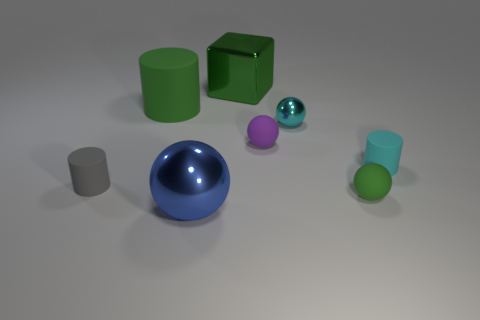How many small things are brown metallic cylinders or cyan metallic things?
Offer a very short reply. 1. Are there any gray objects?
Give a very brief answer. Yes. Are there more tiny purple matte objects that are behind the big green matte cylinder than small shiny spheres to the left of the large blue metal object?
Give a very brief answer. No. There is a metallic object in front of the tiny cylinder to the left of the big green cube; what is its color?
Offer a very short reply. Blue. Is there a big shiny sphere of the same color as the block?
Make the answer very short. No. What size is the gray rubber cylinder that is behind the green thing that is in front of the green matte object that is to the left of the cyan shiny thing?
Give a very brief answer. Small. There is a large green metal thing; what shape is it?
Provide a succinct answer. Cube. What is the size of the rubber thing that is the same color as the big matte cylinder?
Your answer should be very brief. Small. How many small balls are in front of the rubber ball to the right of the tiny cyan ball?
Keep it short and to the point. 0. What number of other objects are there of the same material as the purple ball?
Your answer should be very brief. 4. 